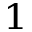<formula> <loc_0><loc_0><loc_500><loc_500>^ { 1 }</formula> 